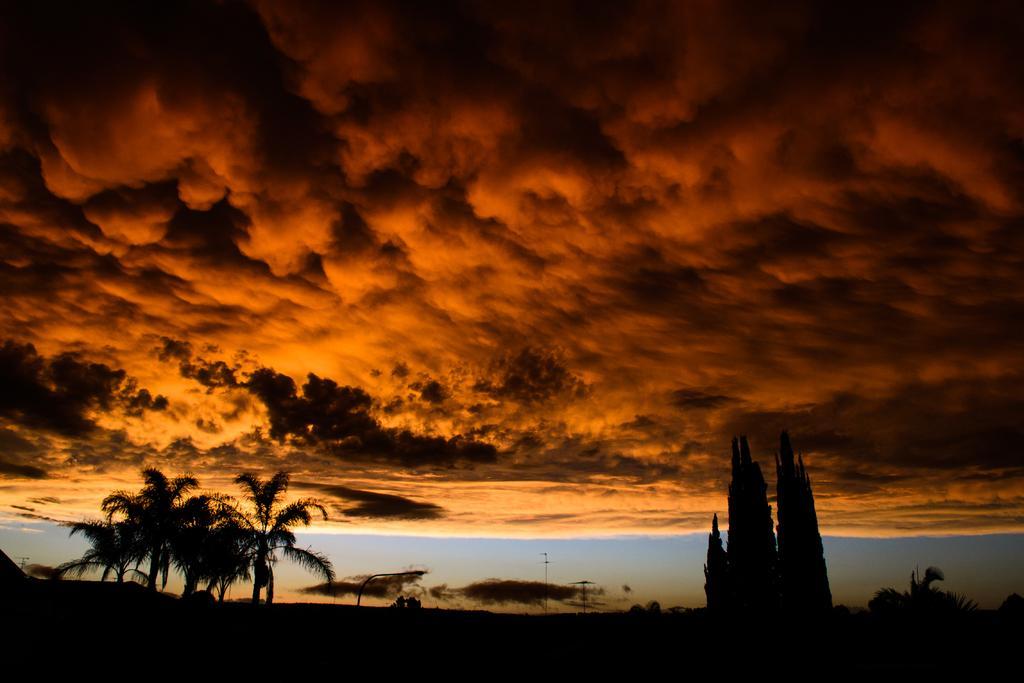Can you describe this image briefly? This is an image clicked in the dark. At the bottom there are some trees. At the top of the image, I can see the sky and clouds. 